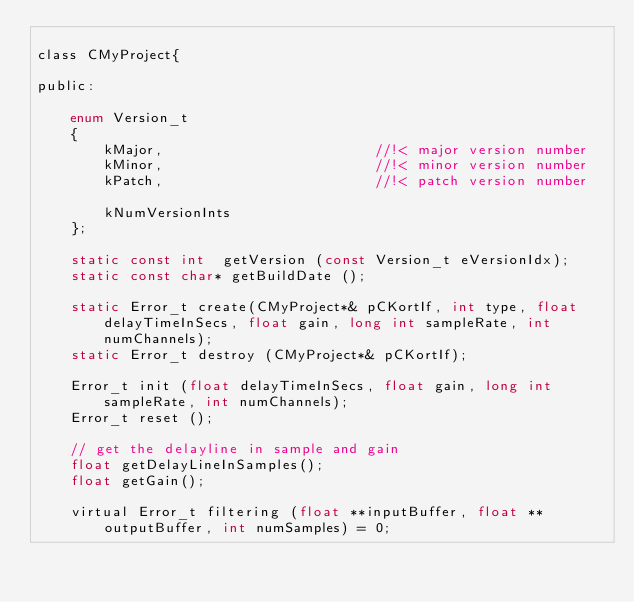<code> <loc_0><loc_0><loc_500><loc_500><_C_>
class CMyProject{
    
public:
    
    enum Version_t
    {
        kMajor,                         //!< major version number
        kMinor,                         //!< minor version number
        kPatch,                         //!< patch version number
        
        kNumVersionInts
    };
    
    static const int  getVersion (const Version_t eVersionIdx);
    static const char* getBuildDate ();
    
    static Error_t create(CMyProject*& pCKortIf, int type, float delayTimeInSecs, float gain, long int sampleRate, int numChannels);
    static Error_t destroy (CMyProject*& pCKortIf);
    
    Error_t init (float delayTimeInSecs, float gain, long int sampleRate, int numChannels);
    Error_t reset ();

    // get the delayline in sample and gain
    float getDelayLineInSamples();
    float getGain();
    
    virtual Error_t filtering (float **inputBuffer, float **outputBuffer, int numSamples) = 0;
    </code> 